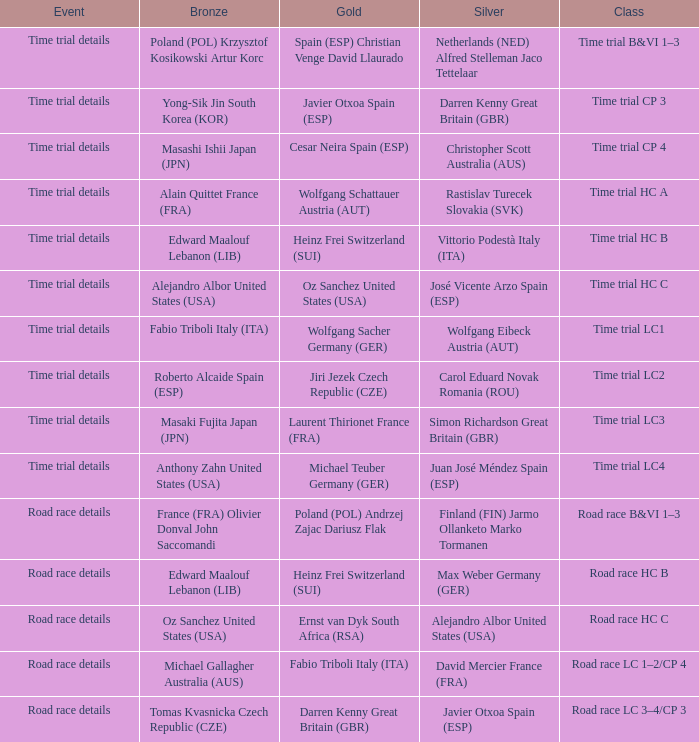What is the event when the class is time trial hc a? Time trial details. 